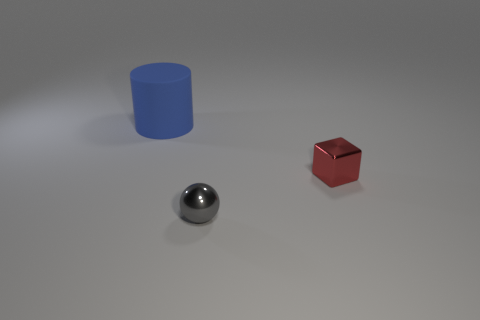Is there any other thing that is the same shape as the big matte thing?
Provide a short and direct response. No. Is the color of the shiny thing that is to the right of the gray sphere the same as the thing that is to the left of the small gray ball?
Give a very brief answer. No. There is a object that is both on the right side of the large blue matte cylinder and behind the gray sphere; what shape is it?
Your answer should be compact. Cube. There is a shiny ball that is the same size as the red block; what is its color?
Give a very brief answer. Gray. Is the size of the metal object that is left of the red cube the same as the shiny object that is behind the metallic sphere?
Provide a succinct answer. Yes. What is the object that is both behind the gray shiny sphere and on the left side of the red metallic block made of?
Your answer should be compact. Rubber. How many other objects are the same size as the blue matte cylinder?
Give a very brief answer. 0. What is the object that is behind the red thing made of?
Make the answer very short. Rubber. How many other objects are the same shape as the blue matte object?
Ensure brevity in your answer.  0. There is a tiny metallic object that is in front of the small red block; what is its color?
Offer a very short reply. Gray. 